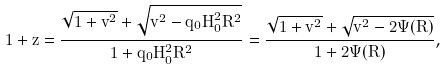<formula> <loc_0><loc_0><loc_500><loc_500>1 + z = \frac { \sqrt { 1 + v ^ { 2 } } + \sqrt { v ^ { 2 } - q _ { 0 } H _ { 0 } ^ { 2 } R ^ { 2 } } } { 1 + q _ { 0 } H _ { 0 } ^ { 2 } R ^ { 2 } } = \frac { \sqrt { 1 + v ^ { 2 } } + \sqrt { v ^ { 2 } - 2 \Psi ( R ) } } { 1 + 2 \Psi ( R ) } ,</formula> 